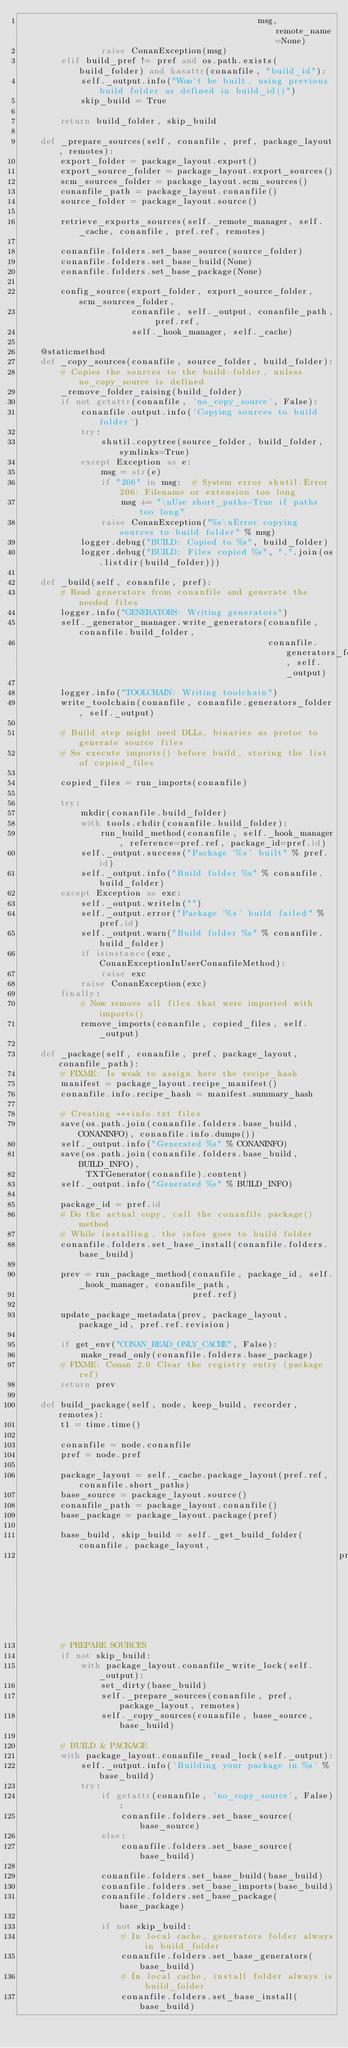Convert code to text. <code><loc_0><loc_0><loc_500><loc_500><_Python_>                                               msg, remote_name=None)
                raise ConanException(msg)
        elif build_pref != pref and os.path.exists(build_folder) and hasattr(conanfile, "build_id"):
            self._output.info("Won't be built, using previous build folder as defined in build_id()")
            skip_build = True

        return build_folder, skip_build

    def _prepare_sources(self, conanfile, pref, package_layout, remotes):
        export_folder = package_layout.export()
        export_source_folder = package_layout.export_sources()
        scm_sources_folder = package_layout.scm_sources()
        conanfile_path = package_layout.conanfile()
        source_folder = package_layout.source()

        retrieve_exports_sources(self._remote_manager, self._cache, conanfile, pref.ref, remotes)

        conanfile.folders.set_base_source(source_folder)
        conanfile.folders.set_base_build(None)
        conanfile.folders.set_base_package(None)

        config_source(export_folder, export_source_folder, scm_sources_folder,
                      conanfile, self._output, conanfile_path, pref.ref,
                      self._hook_manager, self._cache)

    @staticmethod
    def _copy_sources(conanfile, source_folder, build_folder):
        # Copies the sources to the build-folder, unless no_copy_source is defined
        _remove_folder_raising(build_folder)
        if not getattr(conanfile, 'no_copy_source', False):
            conanfile.output.info('Copying sources to build folder')
            try:
                shutil.copytree(source_folder, build_folder, symlinks=True)
            except Exception as e:
                msg = str(e)
                if "206" in msg:  # System error shutil.Error 206: Filename or extension too long
                    msg += "\nUse short_paths=True if paths too long"
                raise ConanException("%s\nError copying sources to build folder" % msg)
            logger.debug("BUILD: Copied to %s", build_folder)
            logger.debug("BUILD: Files copied %s", ",".join(os.listdir(build_folder)))

    def _build(self, conanfile, pref):
        # Read generators from conanfile and generate the needed files
        logger.info("GENERATORS: Writing generators")
        self._generator_manager.write_generators(conanfile, conanfile.build_folder,
                                                 conanfile.generators_folder, self._output)

        logger.info("TOOLCHAIN: Writing toolchain")
        write_toolchain(conanfile, conanfile.generators_folder, self._output)

        # Build step might need DLLs, binaries as protoc to generate source files
        # So execute imports() before build, storing the list of copied_files

        copied_files = run_imports(conanfile)

        try:
            mkdir(conanfile.build_folder)
            with tools.chdir(conanfile.build_folder):
                run_build_method(conanfile, self._hook_manager, reference=pref.ref, package_id=pref.id)
            self._output.success("Package '%s' built" % pref.id)
            self._output.info("Build folder %s" % conanfile.build_folder)
        except Exception as exc:
            self._output.writeln("")
            self._output.error("Package '%s' build failed" % pref.id)
            self._output.warn("Build folder %s" % conanfile.build_folder)
            if isinstance(exc, ConanExceptionInUserConanfileMethod):
                raise exc
            raise ConanException(exc)
        finally:
            # Now remove all files that were imported with imports()
            remove_imports(conanfile, copied_files, self._output)

    def _package(self, conanfile, pref, package_layout, conanfile_path):
        # FIXME: Is weak to assign here the recipe_hash
        manifest = package_layout.recipe_manifest()
        conanfile.info.recipe_hash = manifest.summary_hash

        # Creating ***info.txt files
        save(os.path.join(conanfile.folders.base_build, CONANINFO), conanfile.info.dumps())
        self._output.info("Generated %s" % CONANINFO)
        save(os.path.join(conanfile.folders.base_build, BUILD_INFO),
             TXTGenerator(conanfile).content)
        self._output.info("Generated %s" % BUILD_INFO)

        package_id = pref.id
        # Do the actual copy, call the conanfile.package() method
        # While installing, the infos goes to build folder
        conanfile.folders.set_base_install(conanfile.folders.base_build)

        prev = run_package_method(conanfile, package_id, self._hook_manager, conanfile_path,
                                  pref.ref)

        update_package_metadata(prev, package_layout, package_id, pref.ref.revision)

        if get_env("CONAN_READ_ONLY_CACHE", False):
            make_read_only(conanfile.folders.base_package)
        # FIXME: Conan 2.0 Clear the registry entry (package ref)
        return prev

    def build_package(self, node, keep_build, recorder, remotes):
        t1 = time.time()

        conanfile = node.conanfile
        pref = node.pref

        package_layout = self._cache.package_layout(pref.ref, conanfile.short_paths)
        base_source = package_layout.source()
        conanfile_path = package_layout.conanfile()
        base_package = package_layout.package(pref)

        base_build, skip_build = self._get_build_folder(conanfile, package_layout,
                                                               pref, keep_build, recorder)
        # PREPARE SOURCES
        if not skip_build:
            with package_layout.conanfile_write_lock(self._output):
                set_dirty(base_build)
                self._prepare_sources(conanfile, pref, package_layout, remotes)
                self._copy_sources(conanfile, base_source, base_build)

        # BUILD & PACKAGE
        with package_layout.conanfile_read_lock(self._output):
            self._output.info('Building your package in %s' % base_build)
            try:
                if getattr(conanfile, 'no_copy_source', False):
                    conanfile.folders.set_base_source(base_source)
                else:
                    conanfile.folders.set_base_source(base_build)

                conanfile.folders.set_base_build(base_build)
                conanfile.folders.set_base_imports(base_build)
                conanfile.folders.set_base_package(base_package)

                if not skip_build:
                    # In local cache, generators folder always in build_folder
                    conanfile.folders.set_base_generators(base_build)
                    # In local cache, install folder always is build_folder
                    conanfile.folders.set_base_install(base_build)</code> 